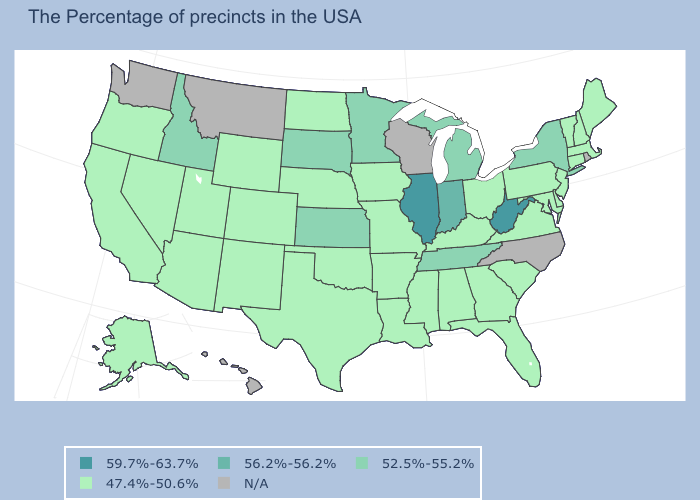Which states have the highest value in the USA?
Keep it brief. West Virginia, Illinois. Among the states that border Oklahoma , which have the highest value?
Concise answer only. Kansas. Does the first symbol in the legend represent the smallest category?
Give a very brief answer. No. What is the value of West Virginia?
Be succinct. 59.7%-63.7%. What is the value of California?
Give a very brief answer. 47.4%-50.6%. Name the states that have a value in the range 56.2%-56.2%?
Keep it brief. Indiana. Name the states that have a value in the range 56.2%-56.2%?
Short answer required. Indiana. How many symbols are there in the legend?
Keep it brief. 5. Does Utah have the lowest value in the USA?
Short answer required. Yes. Does the first symbol in the legend represent the smallest category?
Answer briefly. No. Which states have the lowest value in the USA?
Answer briefly. Maine, Massachusetts, New Hampshire, Vermont, Connecticut, New Jersey, Delaware, Maryland, Pennsylvania, Virginia, South Carolina, Ohio, Florida, Georgia, Kentucky, Alabama, Mississippi, Louisiana, Missouri, Arkansas, Iowa, Nebraska, Oklahoma, Texas, North Dakota, Wyoming, Colorado, New Mexico, Utah, Arizona, Nevada, California, Oregon, Alaska. What is the value of New Hampshire?
Concise answer only. 47.4%-50.6%. Does the first symbol in the legend represent the smallest category?
Give a very brief answer. No. What is the value of Massachusetts?
Quick response, please. 47.4%-50.6%. 